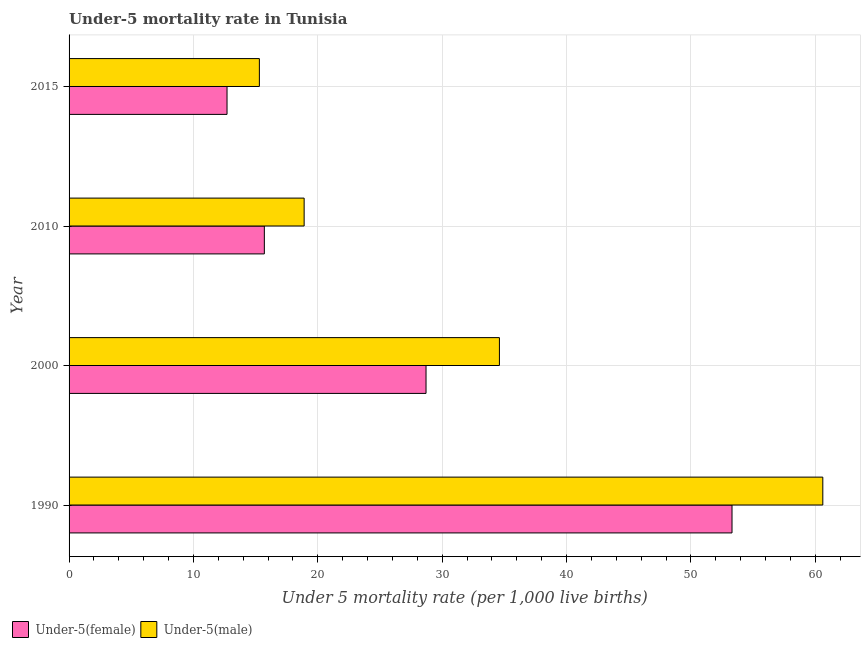Are the number of bars per tick equal to the number of legend labels?
Your answer should be compact. Yes. How many bars are there on the 4th tick from the top?
Keep it short and to the point. 2. How many bars are there on the 3rd tick from the bottom?
Provide a succinct answer. 2. What is the label of the 1st group of bars from the top?
Provide a short and direct response. 2015. Across all years, what is the maximum under-5 female mortality rate?
Ensure brevity in your answer.  53.3. In which year was the under-5 female mortality rate minimum?
Your response must be concise. 2015. What is the total under-5 female mortality rate in the graph?
Provide a short and direct response. 110.4. What is the difference between the under-5 female mortality rate in 1990 and that in 2010?
Keep it short and to the point. 37.6. What is the difference between the under-5 male mortality rate in 1990 and the under-5 female mortality rate in 2000?
Offer a very short reply. 31.9. What is the average under-5 male mortality rate per year?
Provide a short and direct response. 32.35. What is the ratio of the under-5 male mortality rate in 2010 to that in 2015?
Give a very brief answer. 1.24. Is the under-5 female mortality rate in 1990 less than that in 2015?
Your answer should be very brief. No. Is the difference between the under-5 male mortality rate in 2000 and 2015 greater than the difference between the under-5 female mortality rate in 2000 and 2015?
Give a very brief answer. Yes. What is the difference between the highest and the second highest under-5 female mortality rate?
Your answer should be compact. 24.6. What is the difference between the highest and the lowest under-5 female mortality rate?
Offer a very short reply. 40.6. Is the sum of the under-5 male mortality rate in 1990 and 2010 greater than the maximum under-5 female mortality rate across all years?
Make the answer very short. Yes. What does the 1st bar from the top in 2000 represents?
Ensure brevity in your answer.  Under-5(male). What does the 2nd bar from the bottom in 1990 represents?
Ensure brevity in your answer.  Under-5(male). Are all the bars in the graph horizontal?
Your answer should be very brief. Yes. Are the values on the major ticks of X-axis written in scientific E-notation?
Give a very brief answer. No. Does the graph contain grids?
Keep it short and to the point. Yes. Where does the legend appear in the graph?
Make the answer very short. Bottom left. How many legend labels are there?
Give a very brief answer. 2. How are the legend labels stacked?
Keep it short and to the point. Horizontal. What is the title of the graph?
Offer a terse response. Under-5 mortality rate in Tunisia. What is the label or title of the X-axis?
Ensure brevity in your answer.  Under 5 mortality rate (per 1,0 live births). What is the label or title of the Y-axis?
Give a very brief answer. Year. What is the Under 5 mortality rate (per 1,000 live births) of Under-5(female) in 1990?
Make the answer very short. 53.3. What is the Under 5 mortality rate (per 1,000 live births) of Under-5(male) in 1990?
Your response must be concise. 60.6. What is the Under 5 mortality rate (per 1,000 live births) of Under-5(female) in 2000?
Offer a very short reply. 28.7. What is the Under 5 mortality rate (per 1,000 live births) of Under-5(male) in 2000?
Offer a terse response. 34.6. What is the Under 5 mortality rate (per 1,000 live births) of Under-5(female) in 2010?
Keep it short and to the point. 15.7. What is the Under 5 mortality rate (per 1,000 live births) in Under-5(male) in 2010?
Make the answer very short. 18.9. What is the Under 5 mortality rate (per 1,000 live births) in Under-5(female) in 2015?
Your answer should be compact. 12.7. What is the Under 5 mortality rate (per 1,000 live births) of Under-5(male) in 2015?
Provide a succinct answer. 15.3. Across all years, what is the maximum Under 5 mortality rate (per 1,000 live births) in Under-5(female)?
Provide a succinct answer. 53.3. Across all years, what is the maximum Under 5 mortality rate (per 1,000 live births) of Under-5(male)?
Offer a terse response. 60.6. Across all years, what is the minimum Under 5 mortality rate (per 1,000 live births) of Under-5(male)?
Provide a succinct answer. 15.3. What is the total Under 5 mortality rate (per 1,000 live births) of Under-5(female) in the graph?
Offer a very short reply. 110.4. What is the total Under 5 mortality rate (per 1,000 live births) in Under-5(male) in the graph?
Offer a very short reply. 129.4. What is the difference between the Under 5 mortality rate (per 1,000 live births) of Under-5(female) in 1990 and that in 2000?
Your response must be concise. 24.6. What is the difference between the Under 5 mortality rate (per 1,000 live births) in Under-5(female) in 1990 and that in 2010?
Keep it short and to the point. 37.6. What is the difference between the Under 5 mortality rate (per 1,000 live births) of Under-5(male) in 1990 and that in 2010?
Provide a short and direct response. 41.7. What is the difference between the Under 5 mortality rate (per 1,000 live births) in Under-5(female) in 1990 and that in 2015?
Your answer should be very brief. 40.6. What is the difference between the Under 5 mortality rate (per 1,000 live births) of Under-5(male) in 1990 and that in 2015?
Give a very brief answer. 45.3. What is the difference between the Under 5 mortality rate (per 1,000 live births) of Under-5(male) in 2000 and that in 2015?
Offer a very short reply. 19.3. What is the difference between the Under 5 mortality rate (per 1,000 live births) in Under-5(female) in 2010 and that in 2015?
Your response must be concise. 3. What is the difference between the Under 5 mortality rate (per 1,000 live births) in Under-5(male) in 2010 and that in 2015?
Keep it short and to the point. 3.6. What is the difference between the Under 5 mortality rate (per 1,000 live births) in Under-5(female) in 1990 and the Under 5 mortality rate (per 1,000 live births) in Under-5(male) in 2000?
Offer a terse response. 18.7. What is the difference between the Under 5 mortality rate (per 1,000 live births) in Under-5(female) in 1990 and the Under 5 mortality rate (per 1,000 live births) in Under-5(male) in 2010?
Give a very brief answer. 34.4. What is the difference between the Under 5 mortality rate (per 1,000 live births) in Under-5(female) in 1990 and the Under 5 mortality rate (per 1,000 live births) in Under-5(male) in 2015?
Offer a terse response. 38. What is the difference between the Under 5 mortality rate (per 1,000 live births) in Under-5(female) in 2000 and the Under 5 mortality rate (per 1,000 live births) in Under-5(male) in 2015?
Ensure brevity in your answer.  13.4. What is the difference between the Under 5 mortality rate (per 1,000 live births) of Under-5(female) in 2010 and the Under 5 mortality rate (per 1,000 live births) of Under-5(male) in 2015?
Your answer should be very brief. 0.4. What is the average Under 5 mortality rate (per 1,000 live births) of Under-5(female) per year?
Give a very brief answer. 27.6. What is the average Under 5 mortality rate (per 1,000 live births) in Under-5(male) per year?
Ensure brevity in your answer.  32.35. In the year 1990, what is the difference between the Under 5 mortality rate (per 1,000 live births) of Under-5(female) and Under 5 mortality rate (per 1,000 live births) of Under-5(male)?
Provide a succinct answer. -7.3. In the year 2015, what is the difference between the Under 5 mortality rate (per 1,000 live births) of Under-5(female) and Under 5 mortality rate (per 1,000 live births) of Under-5(male)?
Ensure brevity in your answer.  -2.6. What is the ratio of the Under 5 mortality rate (per 1,000 live births) of Under-5(female) in 1990 to that in 2000?
Provide a succinct answer. 1.86. What is the ratio of the Under 5 mortality rate (per 1,000 live births) in Under-5(male) in 1990 to that in 2000?
Your answer should be very brief. 1.75. What is the ratio of the Under 5 mortality rate (per 1,000 live births) of Under-5(female) in 1990 to that in 2010?
Your response must be concise. 3.39. What is the ratio of the Under 5 mortality rate (per 1,000 live births) in Under-5(male) in 1990 to that in 2010?
Offer a terse response. 3.21. What is the ratio of the Under 5 mortality rate (per 1,000 live births) in Under-5(female) in 1990 to that in 2015?
Your answer should be very brief. 4.2. What is the ratio of the Under 5 mortality rate (per 1,000 live births) in Under-5(male) in 1990 to that in 2015?
Keep it short and to the point. 3.96. What is the ratio of the Under 5 mortality rate (per 1,000 live births) of Under-5(female) in 2000 to that in 2010?
Your response must be concise. 1.83. What is the ratio of the Under 5 mortality rate (per 1,000 live births) in Under-5(male) in 2000 to that in 2010?
Provide a short and direct response. 1.83. What is the ratio of the Under 5 mortality rate (per 1,000 live births) of Under-5(female) in 2000 to that in 2015?
Provide a succinct answer. 2.26. What is the ratio of the Under 5 mortality rate (per 1,000 live births) of Under-5(male) in 2000 to that in 2015?
Provide a succinct answer. 2.26. What is the ratio of the Under 5 mortality rate (per 1,000 live births) in Under-5(female) in 2010 to that in 2015?
Give a very brief answer. 1.24. What is the ratio of the Under 5 mortality rate (per 1,000 live births) in Under-5(male) in 2010 to that in 2015?
Ensure brevity in your answer.  1.24. What is the difference between the highest and the second highest Under 5 mortality rate (per 1,000 live births) of Under-5(female)?
Provide a short and direct response. 24.6. What is the difference between the highest and the lowest Under 5 mortality rate (per 1,000 live births) in Under-5(female)?
Make the answer very short. 40.6. What is the difference between the highest and the lowest Under 5 mortality rate (per 1,000 live births) of Under-5(male)?
Offer a very short reply. 45.3. 